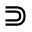<formula> <loc_0><loc_0><loc_500><loc_500>\S u p s e t</formula> 